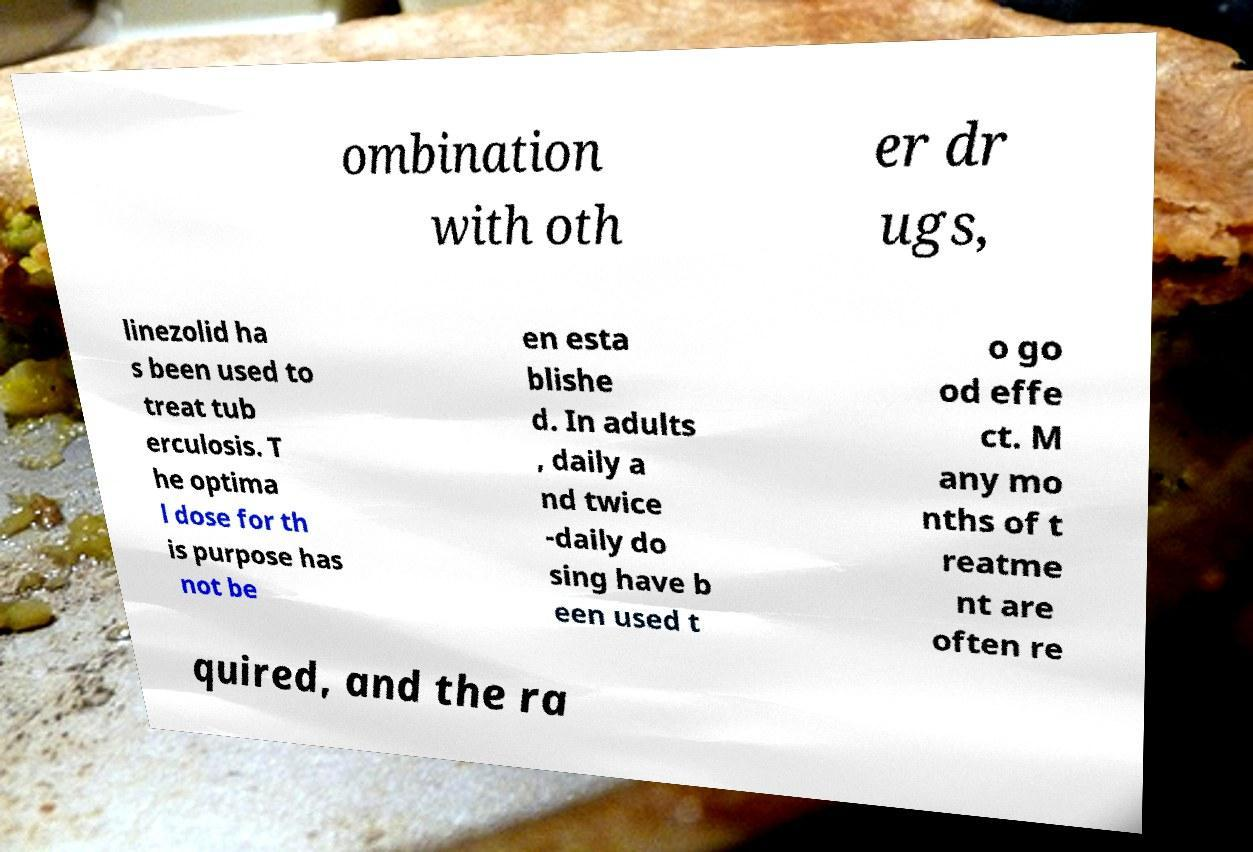Can you read and provide the text displayed in the image?This photo seems to have some interesting text. Can you extract and type it out for me? ombination with oth er dr ugs, linezolid ha s been used to treat tub erculosis. T he optima l dose for th is purpose has not be en esta blishe d. In adults , daily a nd twice -daily do sing have b een used t o go od effe ct. M any mo nths of t reatme nt are often re quired, and the ra 